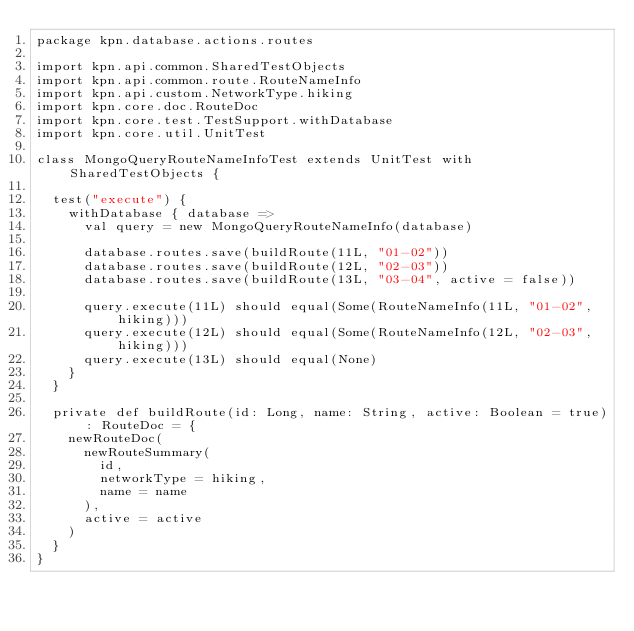Convert code to text. <code><loc_0><loc_0><loc_500><loc_500><_Scala_>package kpn.database.actions.routes

import kpn.api.common.SharedTestObjects
import kpn.api.common.route.RouteNameInfo
import kpn.api.custom.NetworkType.hiking
import kpn.core.doc.RouteDoc
import kpn.core.test.TestSupport.withDatabase
import kpn.core.util.UnitTest

class MongoQueryRouteNameInfoTest extends UnitTest with SharedTestObjects {

  test("execute") {
    withDatabase { database =>
      val query = new MongoQueryRouteNameInfo(database)

      database.routes.save(buildRoute(11L, "01-02"))
      database.routes.save(buildRoute(12L, "02-03"))
      database.routes.save(buildRoute(13L, "03-04", active = false))

      query.execute(11L) should equal(Some(RouteNameInfo(11L, "01-02", hiking)))
      query.execute(12L) should equal(Some(RouteNameInfo(12L, "02-03", hiking)))
      query.execute(13L) should equal(None)
    }
  }

  private def buildRoute(id: Long, name: String, active: Boolean = true): RouteDoc = {
    newRouteDoc(
      newRouteSummary(
        id,
        networkType = hiking,
        name = name
      ),
      active = active
    )
  }
}
</code> 